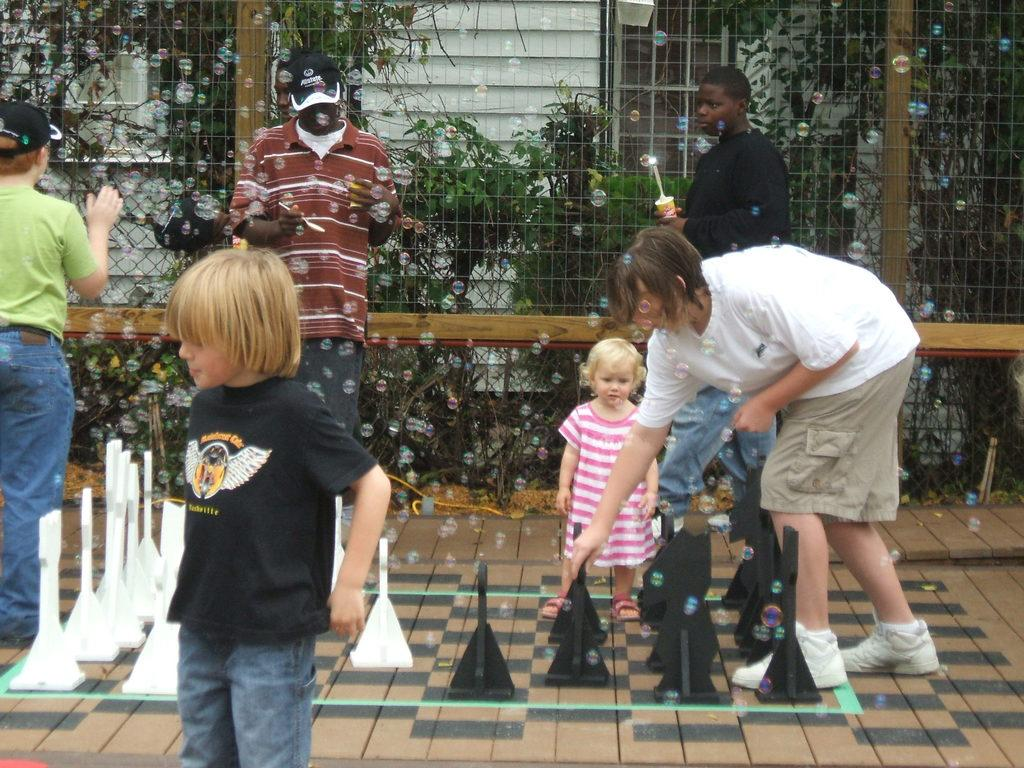What activity are the people engaged in on the pavement? The people are playing chess on the pavement. What else can be seen happening in the image? Some people are blowing bubbles. What can be seen separating the area from another space? There is a fence visible in the image. What can be seen in the distance in the image? Trees and buildings are present in the background of the image. What type of orange is being sold at the store in the image? There is no store or orange present in the image. What part of the body is visible in the image? There is no specific body part visible in the image; the focus is on the people and their activities. 